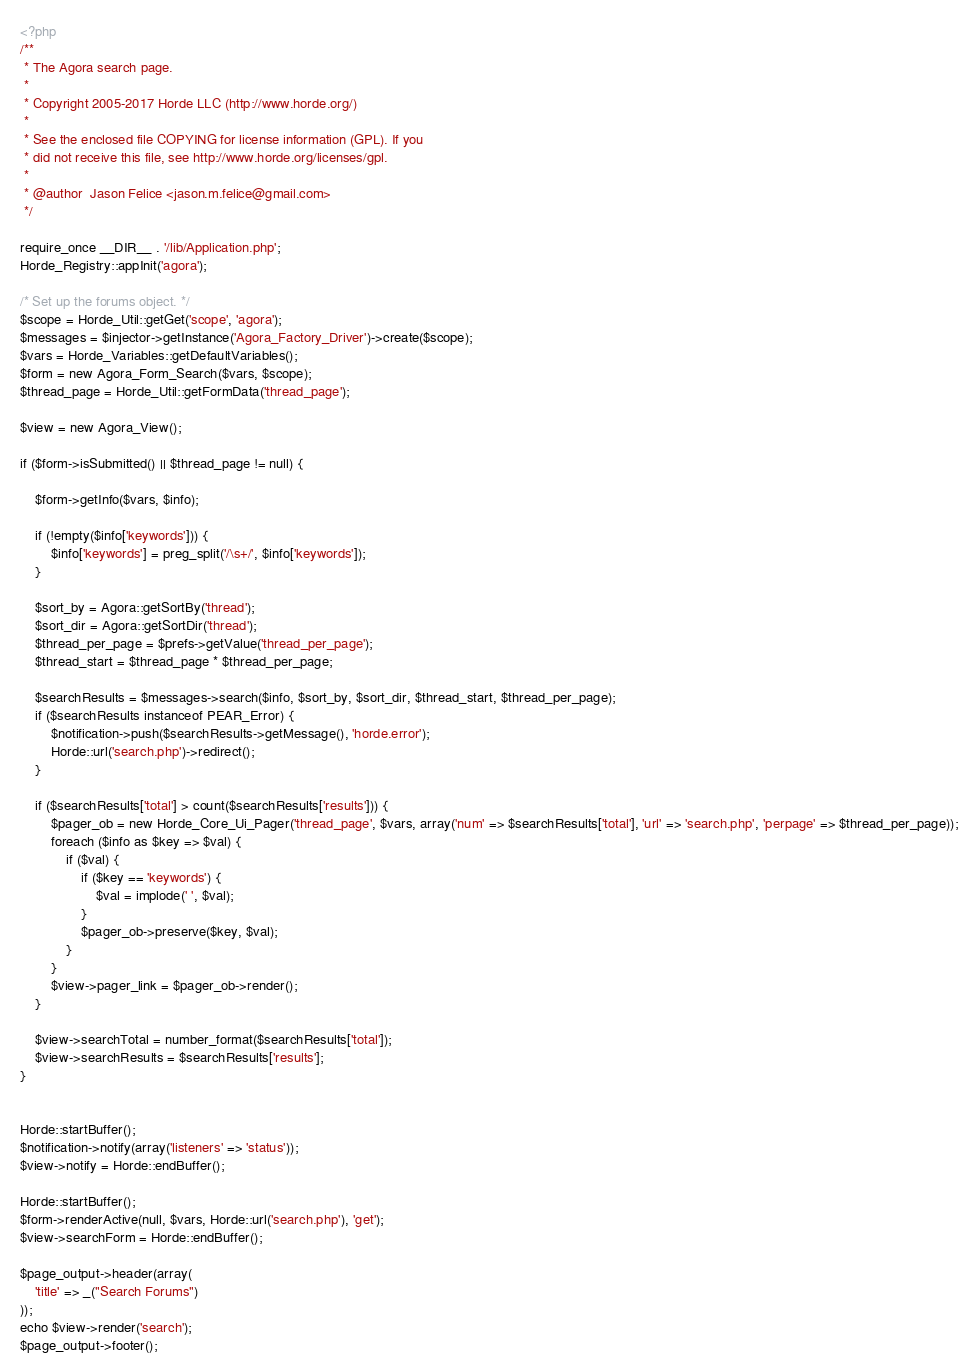Convert code to text. <code><loc_0><loc_0><loc_500><loc_500><_PHP_><?php
/**
 * The Agora search page.
 *
 * Copyright 2005-2017 Horde LLC (http://www.horde.org/)
 *
 * See the enclosed file COPYING for license information (GPL). If you
 * did not receive this file, see http://www.horde.org/licenses/gpl.
 *
 * @author  Jason Felice <jason.m.felice@gmail.com>
 */

require_once __DIR__ . '/lib/Application.php';
Horde_Registry::appInit('agora');

/* Set up the forums object. */
$scope = Horde_Util::getGet('scope', 'agora');
$messages = $injector->getInstance('Agora_Factory_Driver')->create($scope);
$vars = Horde_Variables::getDefaultVariables();
$form = new Agora_Form_Search($vars, $scope);
$thread_page = Horde_Util::getFormData('thread_page');

$view = new Agora_View();

if ($form->isSubmitted() || $thread_page != null) {

    $form->getInfo($vars, $info);

    if (!empty($info['keywords'])) {
        $info['keywords'] = preg_split('/\s+/', $info['keywords']);
    }

    $sort_by = Agora::getSortBy('thread');
    $sort_dir = Agora::getSortDir('thread');
    $thread_per_page = $prefs->getValue('thread_per_page');
    $thread_start = $thread_page * $thread_per_page;

    $searchResults = $messages->search($info, $sort_by, $sort_dir, $thread_start, $thread_per_page);
    if ($searchResults instanceof PEAR_Error) {
        $notification->push($searchResults->getMessage(), 'horde.error');
        Horde::url('search.php')->redirect();
    }

    if ($searchResults['total'] > count($searchResults['results'])) {
        $pager_ob = new Horde_Core_Ui_Pager('thread_page', $vars, array('num' => $searchResults['total'], 'url' => 'search.php', 'perpage' => $thread_per_page));
        foreach ($info as $key => $val) {
            if ($val) {
                if ($key == 'keywords') {
                    $val = implode(' ', $val);
                }
                $pager_ob->preserve($key, $val);
            }
        }
        $view->pager_link = $pager_ob->render();
    }

    $view->searchTotal = number_format($searchResults['total']);
    $view->searchResults = $searchResults['results'];
}


Horde::startBuffer();
$notification->notify(array('listeners' => 'status'));
$view->notify = Horde::endBuffer();

Horde::startBuffer();
$form->renderActive(null, $vars, Horde::url('search.php'), 'get');
$view->searchForm = Horde::endBuffer();

$page_output->header(array(
    'title' => _("Search Forums")
));
echo $view->render('search');
$page_output->footer();
</code> 